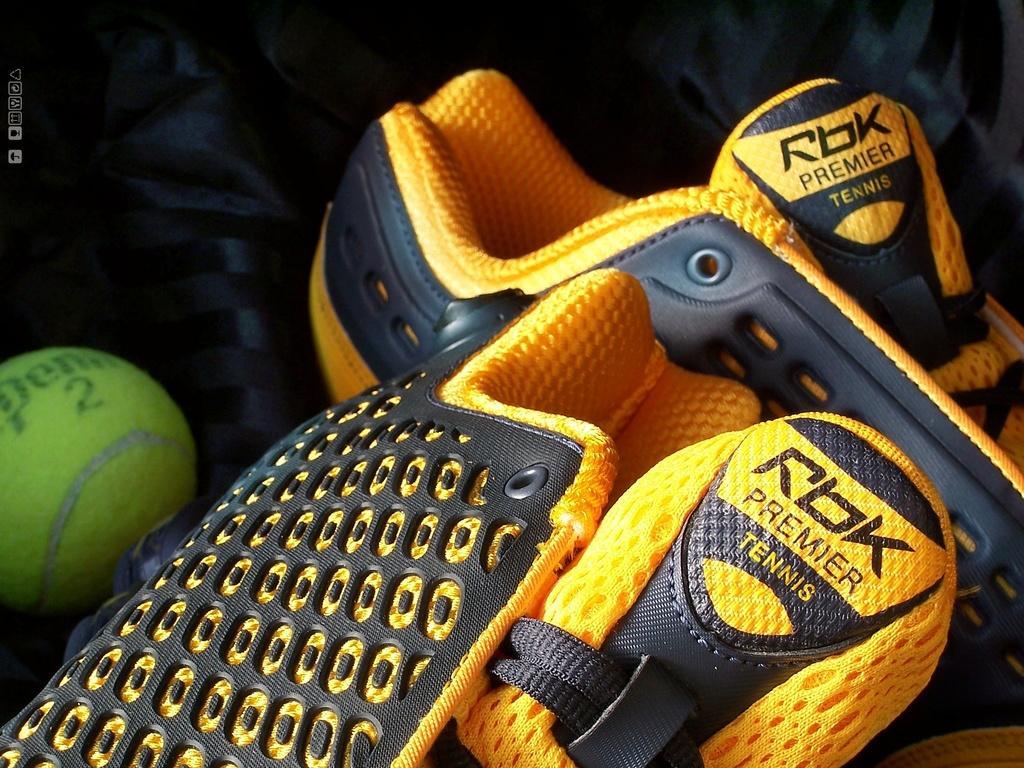How would you summarize this image in a sentence or two? In the picture I can see shoes which are in yellow and black color and there is a ball which is in green color. 